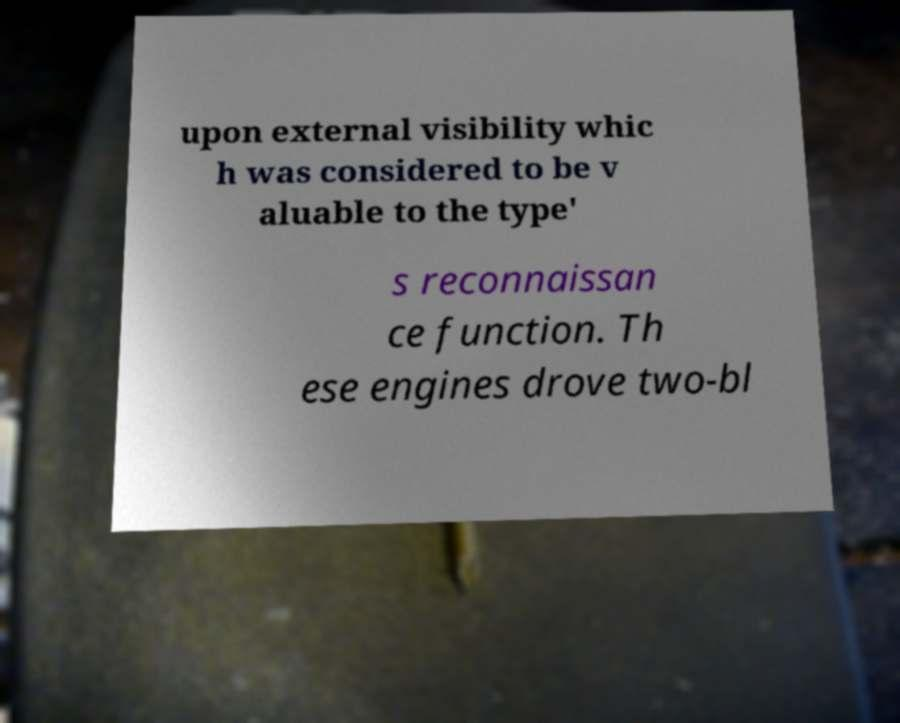For documentation purposes, I need the text within this image transcribed. Could you provide that? upon external visibility whic h was considered to be v aluable to the type' s reconnaissan ce function. Th ese engines drove two-bl 